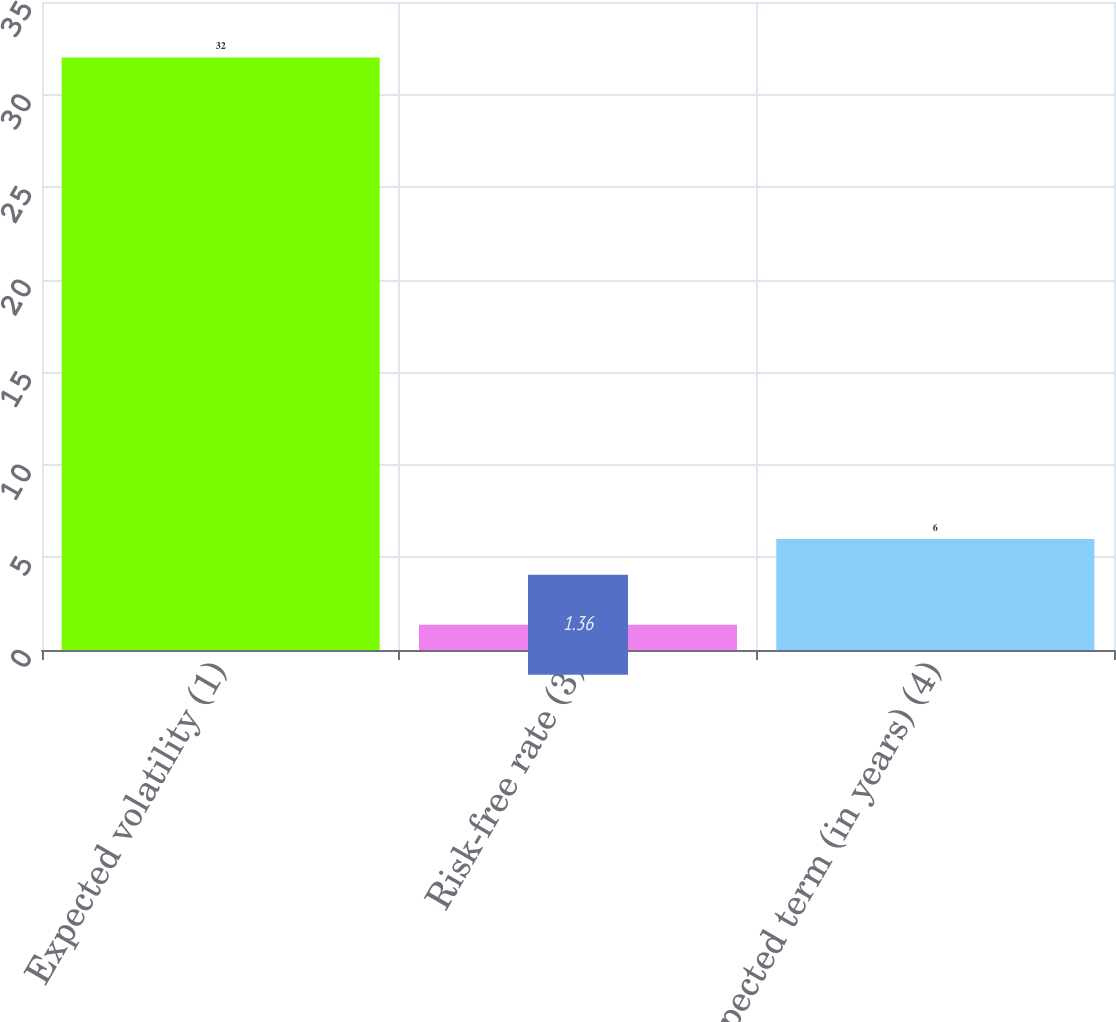Convert chart to OTSL. <chart><loc_0><loc_0><loc_500><loc_500><bar_chart><fcel>Expected volatility (1)<fcel>Risk-free rate (3)<fcel>Expected term (in years) (4)<nl><fcel>32<fcel>1.36<fcel>6<nl></chart> 